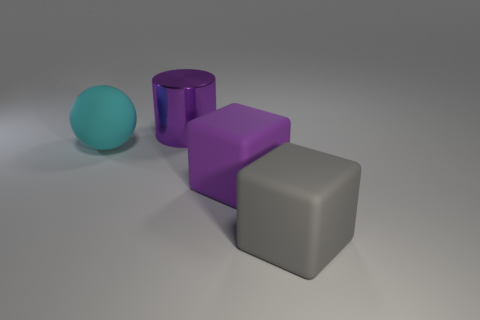Is there any other thing that has the same material as the purple cylinder?
Make the answer very short. No. Does the large metal cylinder behind the big cyan sphere have the same color as the large rubber block that is behind the gray rubber object?
Provide a short and direct response. Yes. Is there a purple block that has the same material as the sphere?
Offer a terse response. Yes. Are there the same number of large things behind the metal object and big metal cylinders that are behind the gray block?
Provide a short and direct response. No. What size is the purple rubber cube to the right of the large cyan ball?
Give a very brief answer. Large. There is a large object on the right side of the purple object that is in front of the cylinder; what is its material?
Provide a succinct answer. Rubber. There is a big purple shiny cylinder that is left of the purple object that is in front of the purple metallic cylinder; how many large balls are in front of it?
Your answer should be compact. 1. Are the big purple object that is to the right of the large purple shiny thing and the object left of the metallic cylinder made of the same material?
Make the answer very short. Yes. How many big purple objects have the same shape as the gray matte object?
Your answer should be very brief. 1. Are there more matte things to the right of the purple metallic cylinder than big gray matte blocks?
Provide a short and direct response. Yes. 